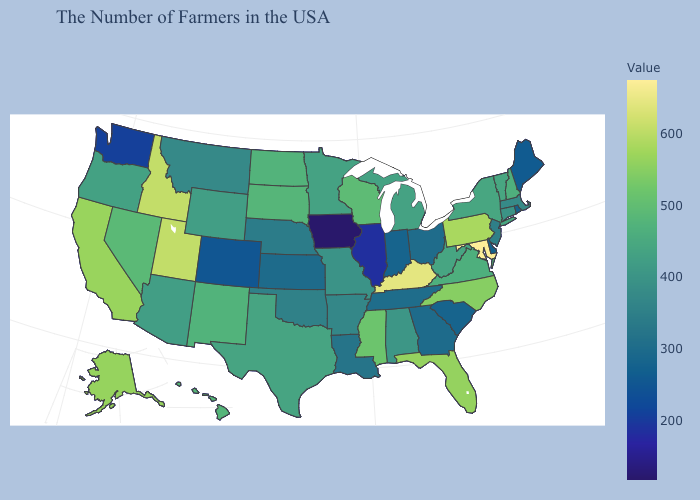Among the states that border Massachusetts , which have the lowest value?
Quick response, please. Rhode Island. Does Iowa have the lowest value in the USA?
Answer briefly. Yes. Which states have the lowest value in the USA?
Short answer required. Iowa. Does Montana have a lower value than Rhode Island?
Keep it brief. No. Does Texas have a lower value than Ohio?
Give a very brief answer. No. Does Oklahoma have a higher value than Illinois?
Short answer required. Yes. 